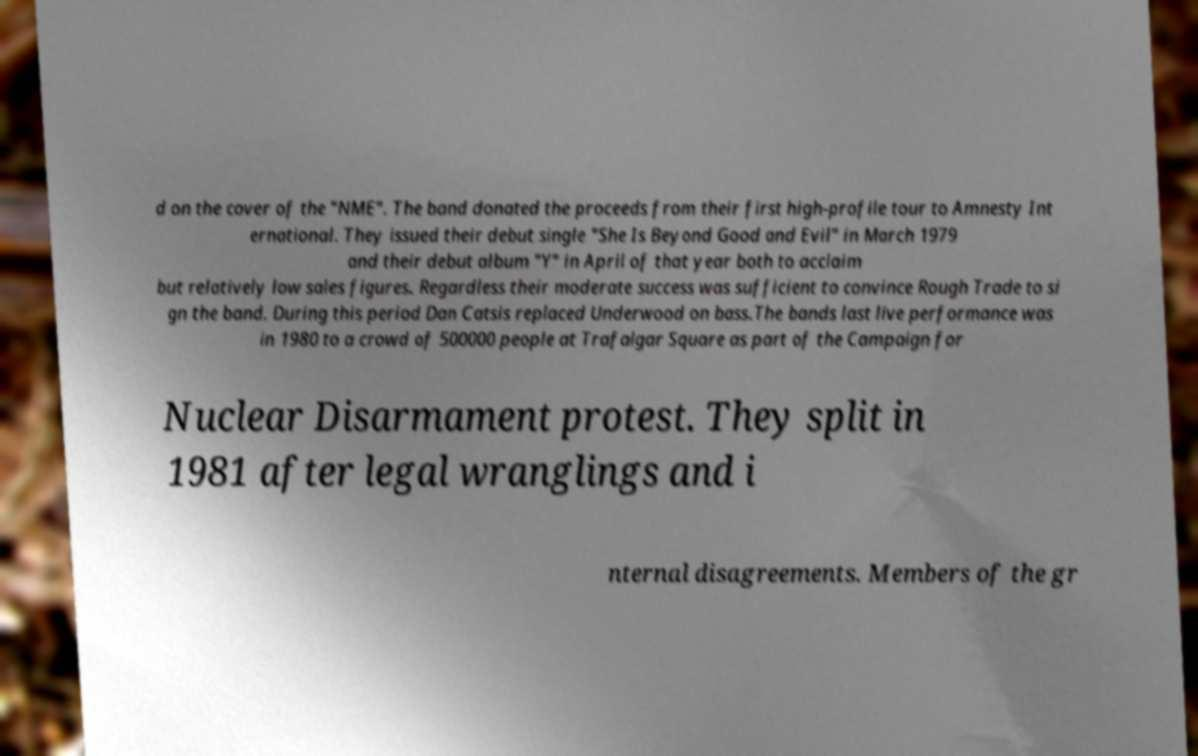There's text embedded in this image that I need extracted. Can you transcribe it verbatim? d on the cover of the "NME". The band donated the proceeds from their first high-profile tour to Amnesty Int ernational. They issued their debut single "She Is Beyond Good and Evil" in March 1979 and their debut album "Y" in April of that year both to acclaim but relatively low sales figures. Regardless their moderate success was sufficient to convince Rough Trade to si gn the band. During this period Dan Catsis replaced Underwood on bass.The bands last live performance was in 1980 to a crowd of 500000 people at Trafalgar Square as part of the Campaign for Nuclear Disarmament protest. They split in 1981 after legal wranglings and i nternal disagreements. Members of the gr 